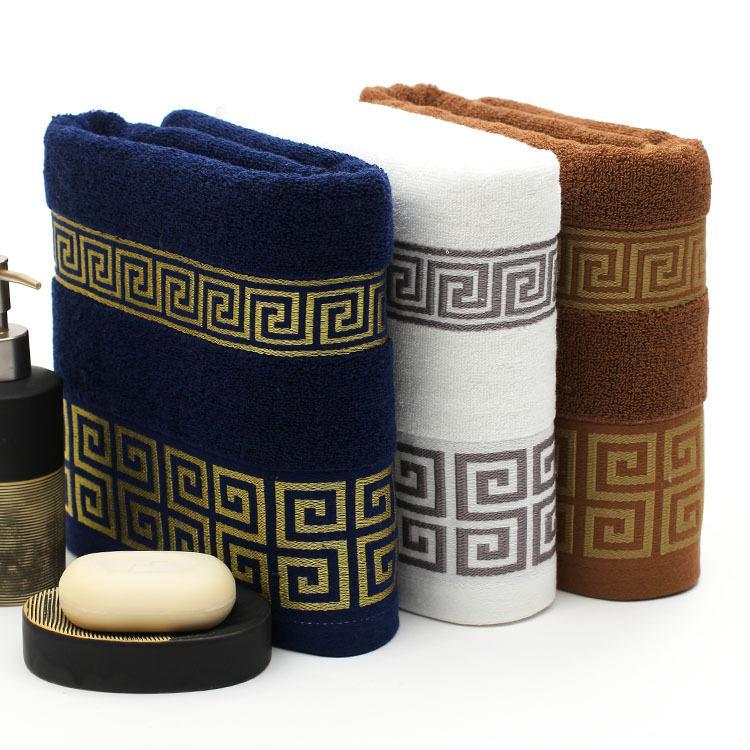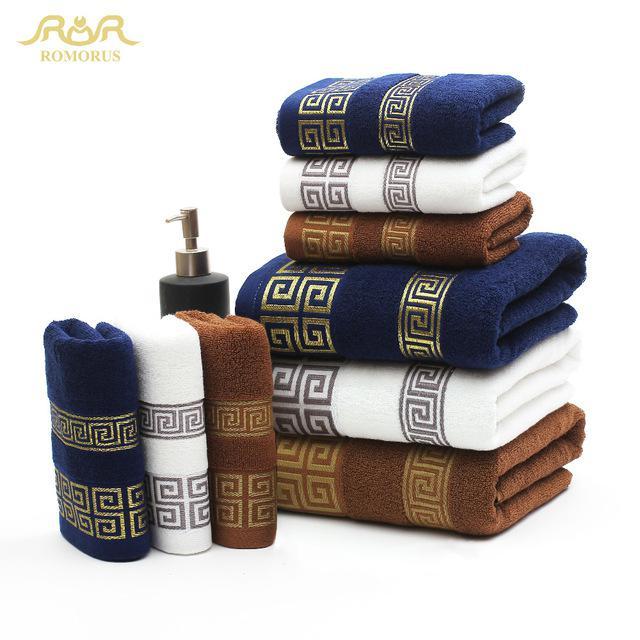The first image is the image on the left, the second image is the image on the right. Considering the images on both sides, is "The left image shows exactly three towels, in navy, white and brown, with gold bands of """"Greek key"""" patterns on the towel's edge." valid? Answer yes or no. Yes. The first image is the image on the left, the second image is the image on the right. Assess this claim about the two images: "In at least one image there is a tower of three folded towels.". Correct or not? Answer yes or no. No. 